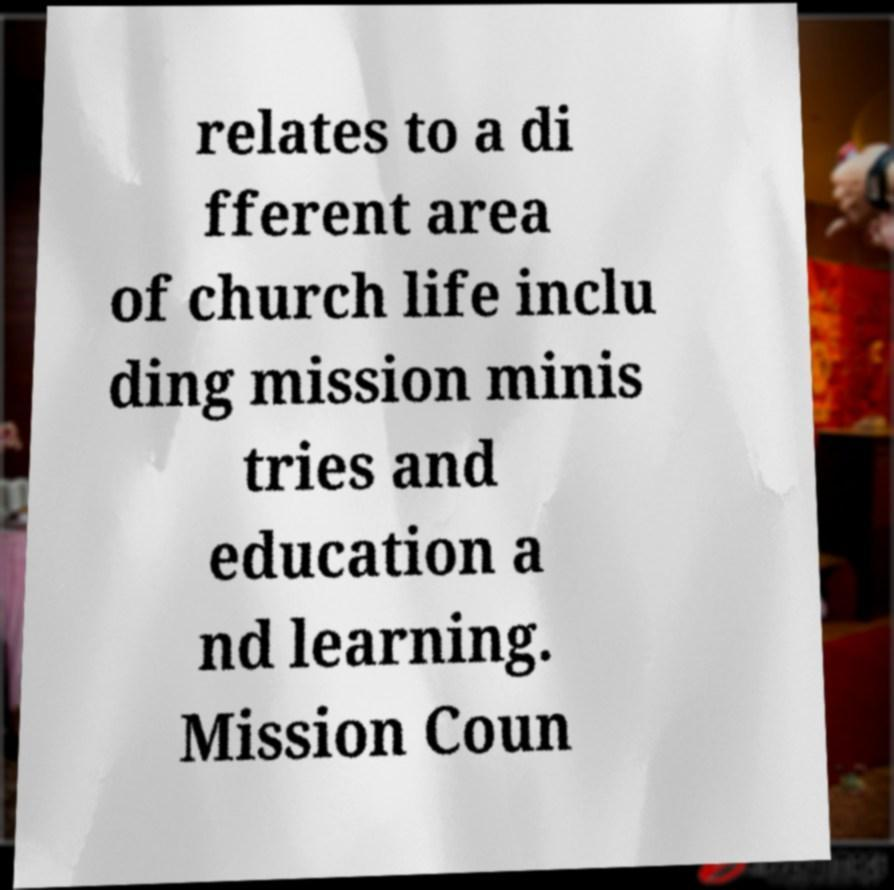Please identify and transcribe the text found in this image. relates to a di fferent area of church life inclu ding mission minis tries and education a nd learning. Mission Coun 